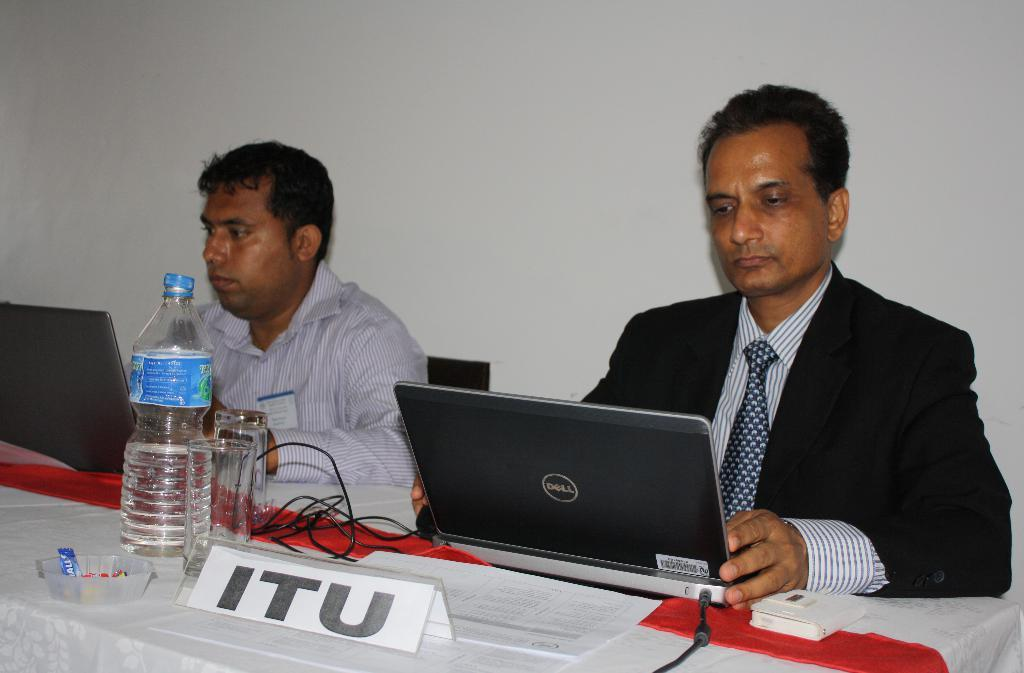<image>
Present a compact description of the photo's key features. A man wearing a black suit is at a table using a Dell laptop. 